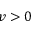<formula> <loc_0><loc_0><loc_500><loc_500>v > 0</formula> 